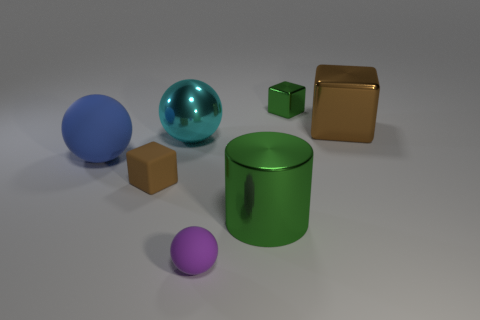There is a object that is both in front of the big blue thing and to the left of the metallic ball; what material is it?
Your answer should be compact. Rubber. What is the size of the rubber object right of the shiny thing left of the thing that is in front of the big metallic cylinder?
Provide a short and direct response. Small. There is a big matte thing; is it the same shape as the big cyan metal thing that is behind the blue rubber thing?
Your answer should be very brief. Yes. What number of objects are both behind the purple rubber ball and in front of the brown metallic object?
Give a very brief answer. 4. What number of purple objects are small matte things or tiny balls?
Make the answer very short. 1. Does the small cube that is behind the big brown cube have the same color as the cube that is to the right of the green shiny cube?
Ensure brevity in your answer.  No. What color is the matte sphere on the left side of the tiny cube in front of the large shiny block behind the brown rubber object?
Your answer should be compact. Blue. There is a large ball that is to the left of the matte cube; are there any cyan metallic spheres that are in front of it?
Make the answer very short. No. There is a large object left of the metallic ball; is it the same shape as the cyan metal object?
Offer a terse response. Yes. Are there any other things that are the same shape as the big matte object?
Your answer should be compact. Yes. 